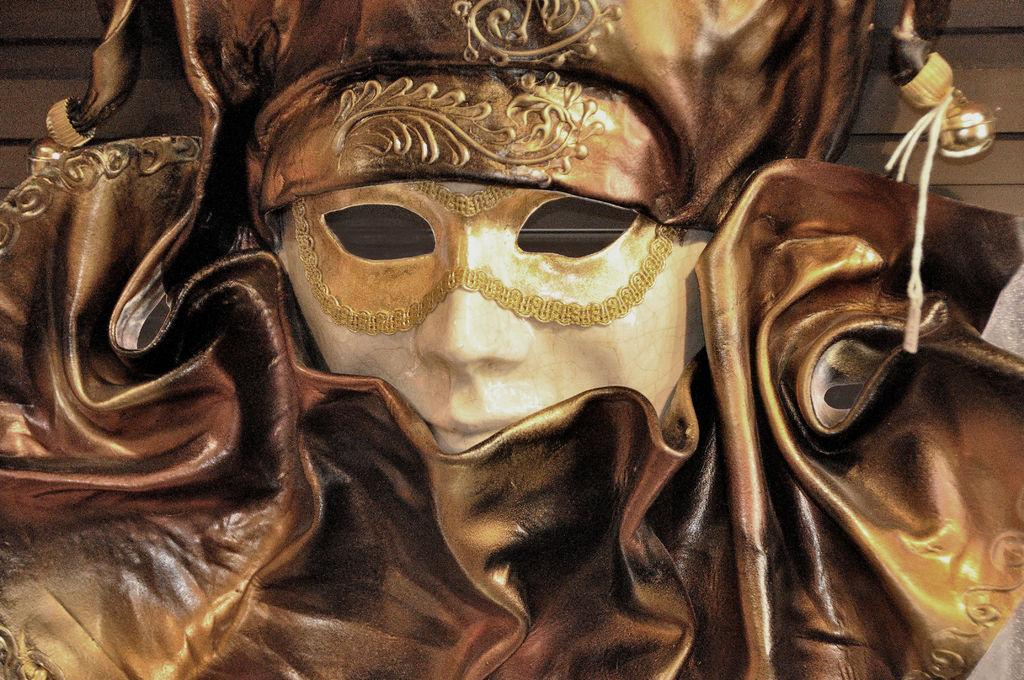What object is located in the center of the image? There is a mask in the center of the image. What is the color of the mask? The mask is brown in color. What type of stone is used to make the wish in the image? There is no stone or wish present in the image; it only features a brown mask. 